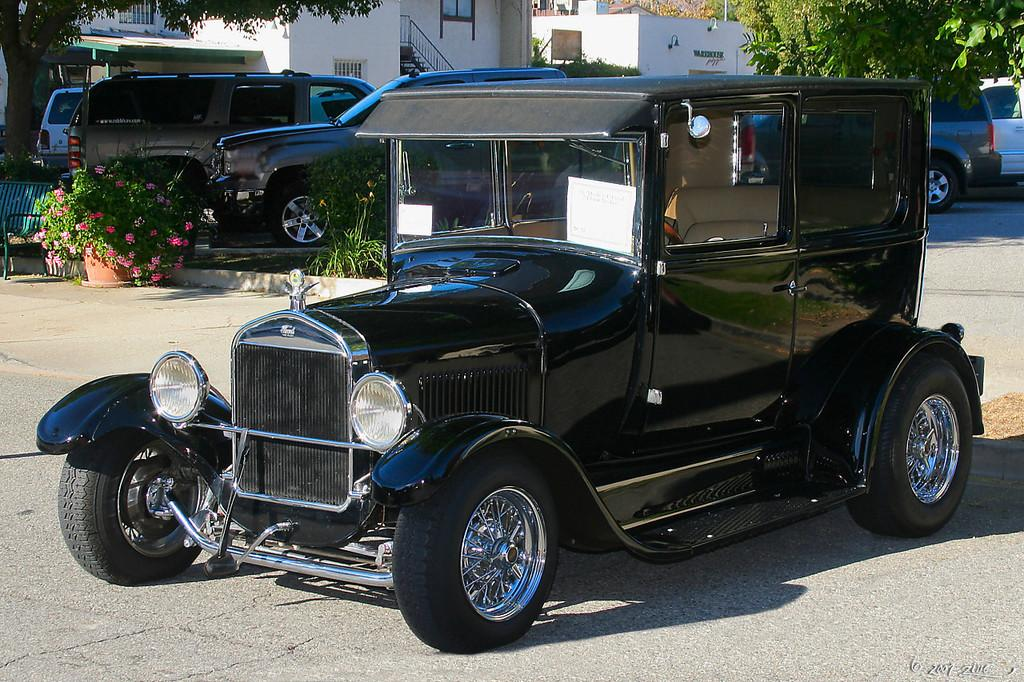What type of vehicle is in the image? There is an antique car in the image. Where is the antique car located? The car is on the road surface. What can be seen behind the antique car? There are buildings and trees behind the antique car. What else is visible in the image? There are other cars parked in front of the buildings. What type of wax is being used to polish the drum in the image? There is no drum or wax present in the image; it features an antique car on the road surface with buildings and trees in the background. 